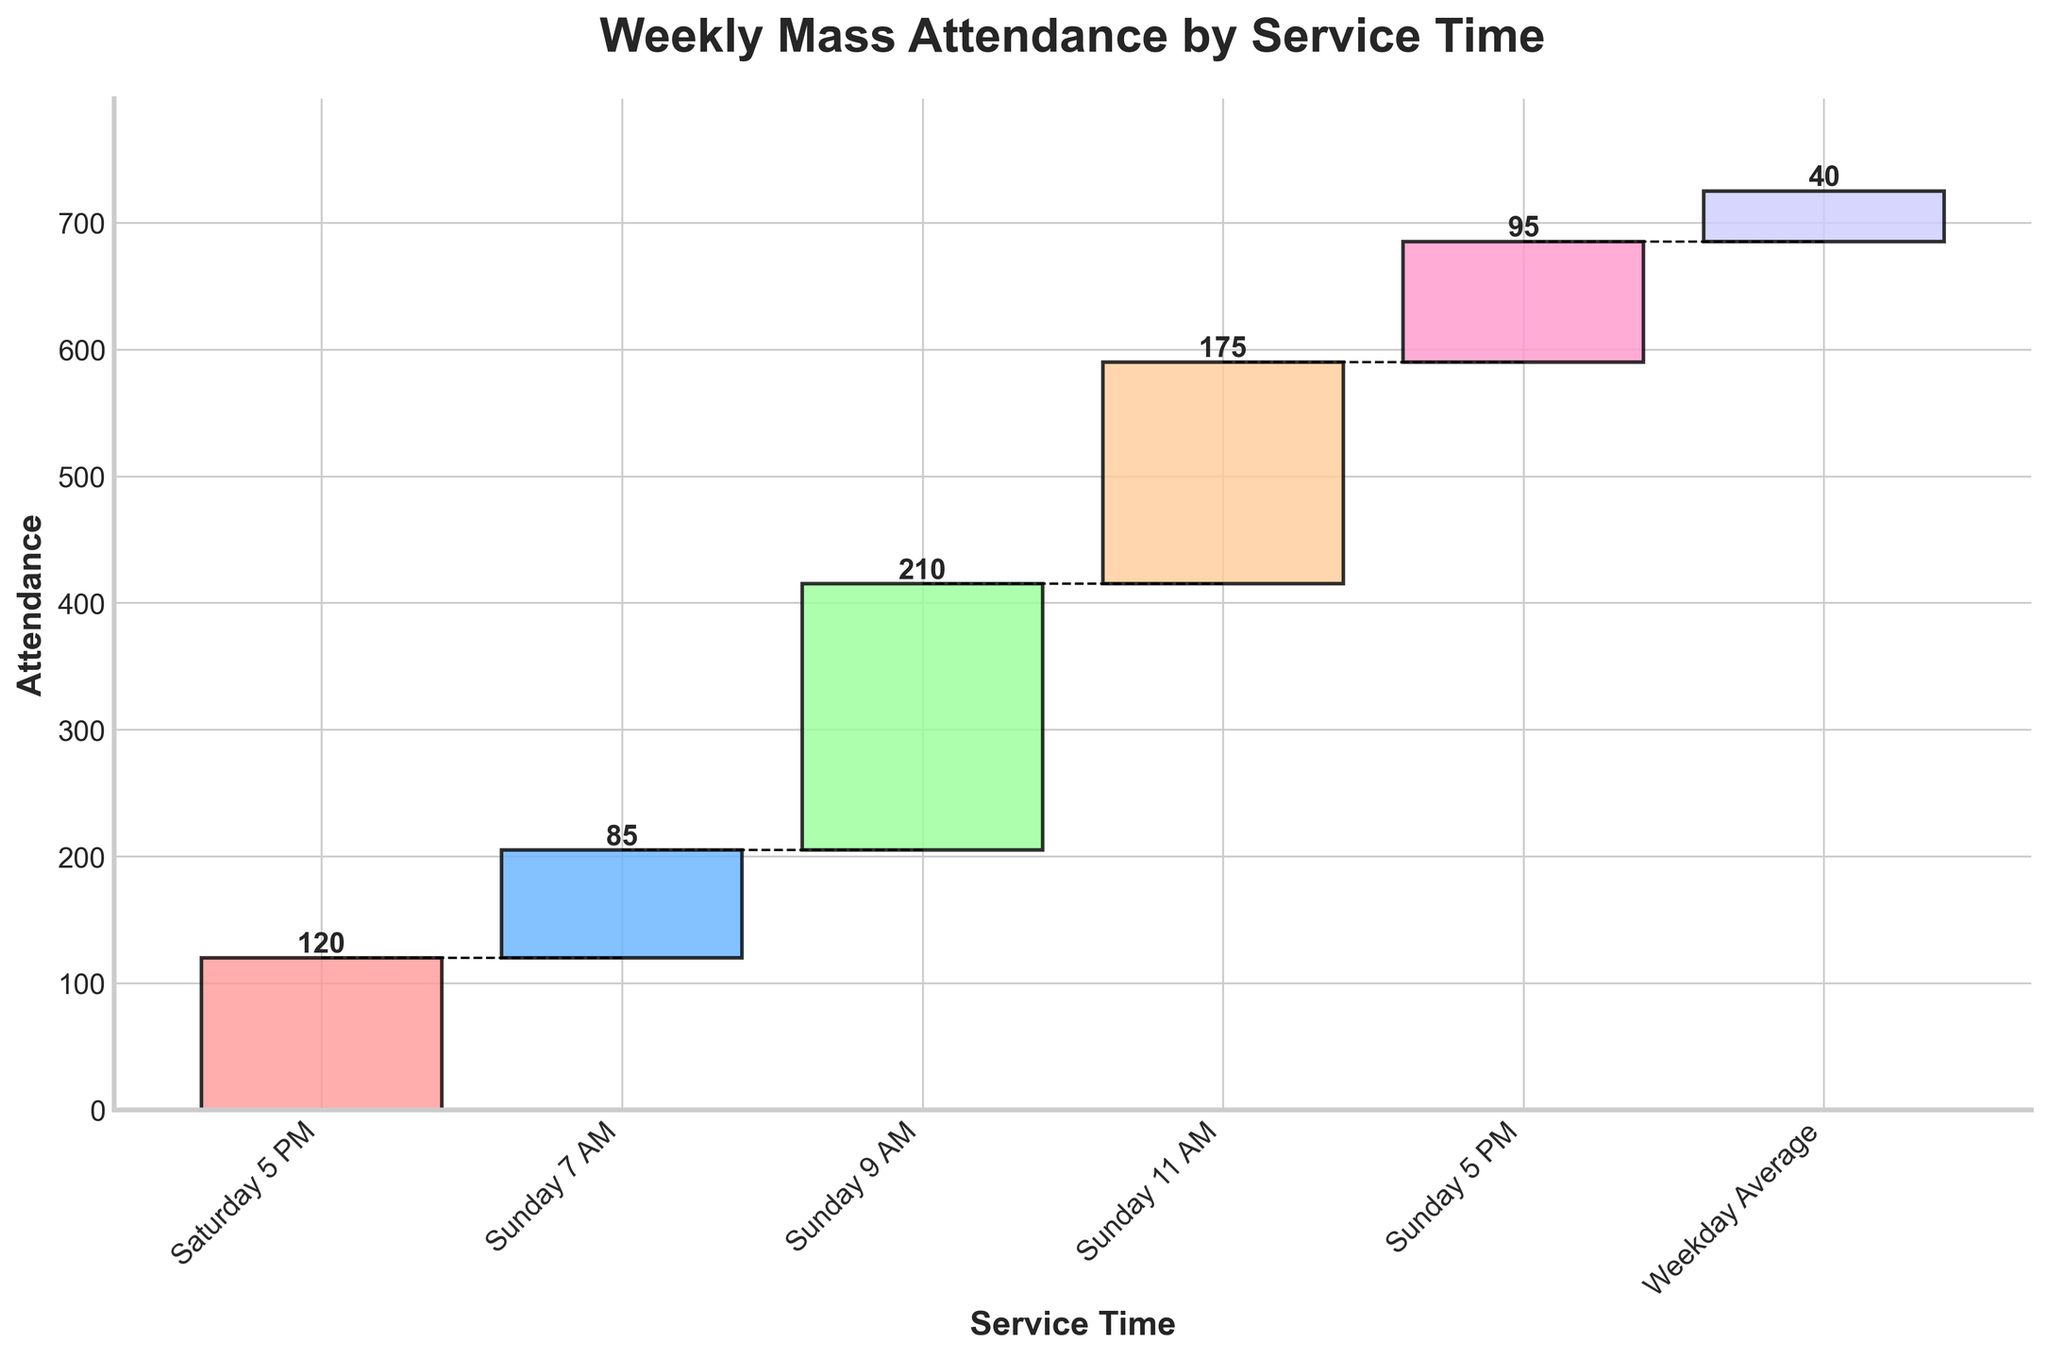What is the title of the chart? The title of the chart is typically found at the top and describes the main topic. In this figure, it reads "Weekly Mass Attendance by Service Time" as it summarizes the attendance data over different services.
Answer: Weekly Mass Attendance by Service Time What are the service times listed on the x-axis? The x-axis displays different service times which are labeled in natural language terms. According to the chart, the services listed are "Saturday 5 PM," "Sunday 7 AM," "Sunday 9 AM," "Sunday 11 AM," and "Sunday 5 PM."
Answer: Saturday 5 PM, Sunday 7 AM, Sunday 9 AM, Sunday 11 AM, Sunday 5 PM What is the total weekly attendance for Mass? At the very end of the cumulative bars and in the data provided, the total weekly attendance is directly given. It is labeled as "Total" in the data.
Answer: 725 Which service time had the highest attendance? To determine which service had the highest attendance, you compare the heights of the individual bars. The tallest bar represents the 9 AM service on Sunday with an attendance of 210.
Answer: Sunday 9 AM How does the attendance at Sunday 5 PM compare to Sunday 7 AM? You compare the heights of the bars corresponding to Sunday 5 PM and Sunday 7 AM. Sunday 5 PM has an attendance of 95, while Sunday 7 AM has an attendance of 85. So, Sunday 5 PM has a higher attendance.
Answer: Sunday 5 PM What is the average attendance for all services listed? To calculate the average attendance, you sum up the attendance of all listed services and then divide by the number of services. The services' attendances are 120, 85, 210, 175, and 95. Summing these gives 685, and there are 5 services. So, the average is 685/5.
Answer: 137 What is the cumulative attendance after the Sunday 11 AM service? Cumulative attendance is the total attendance up to a certain point. After the Sunday 11 AM service, you add the attendance from all prior services, which includes Saturday 5 PM, Sunday 7 AM, Sunday 9 AM, and Sunday 11 AM. This gives 120 + 85 + 210 + 175 = 590.
Answer: 590 What is the smallest increase in attendance between consecutive services? To find the smallest increase, you look at the difference in cumulative attendance between each consecutive pair of services. The differences are 120 (Saturday 5 PM), 85 (Sunday 7 AM), 125 (Sunday 9 AM), 135 (Sunday 11 AM), and 95 (Sunday 5 PM). The smallest of these increases is between Saturday 5 PM and Sunday 7 AM, which is 85.
Answer: Between Saturday 5 PM and Sunday 7 AM How does the cumulative attendance after Sunday 11 AM compare to the total attendance? The cumulative attendance after Sunday 11 AM is 590. The total attendance for all services combined is 725. So, the cumulative attendance is less than the total attendance.
Answer: Less than total What is the range of attendance values across all services? The range is calculated by subtracting the smallest value from the largest value. The smallest attendance is Sunday 7 AM with 85, and the largest is Sunday 9 AM with 210, giving a range of 210 - 85.
Answer: 125 